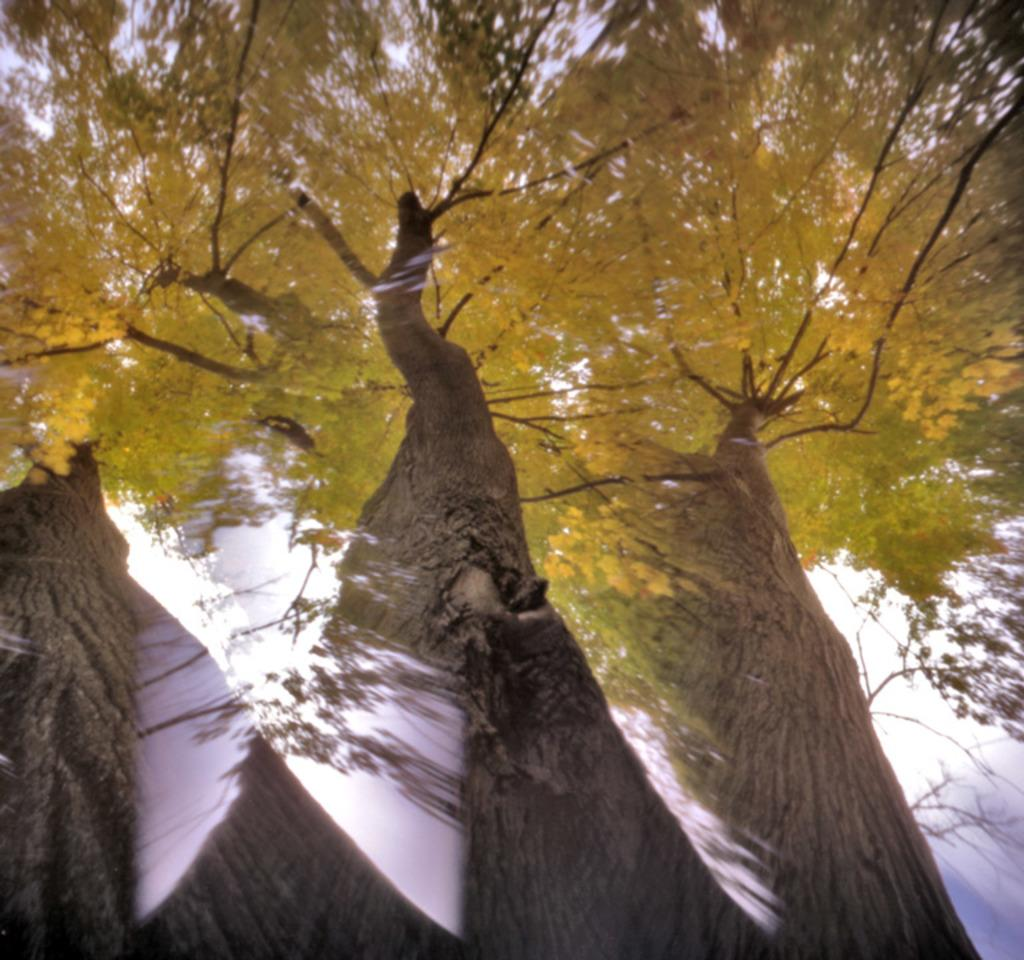What type of vegetation can be seen in the image? There are trees in the image. What part of the natural environment is visible in the image? The sky is visible in the image. What type of yoke is being used by the truck in the image? There is no truck present in the image, so there is no yoke to be used. 